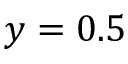<formula> <loc_0><loc_0><loc_500><loc_500>y = 0 . 5</formula> 